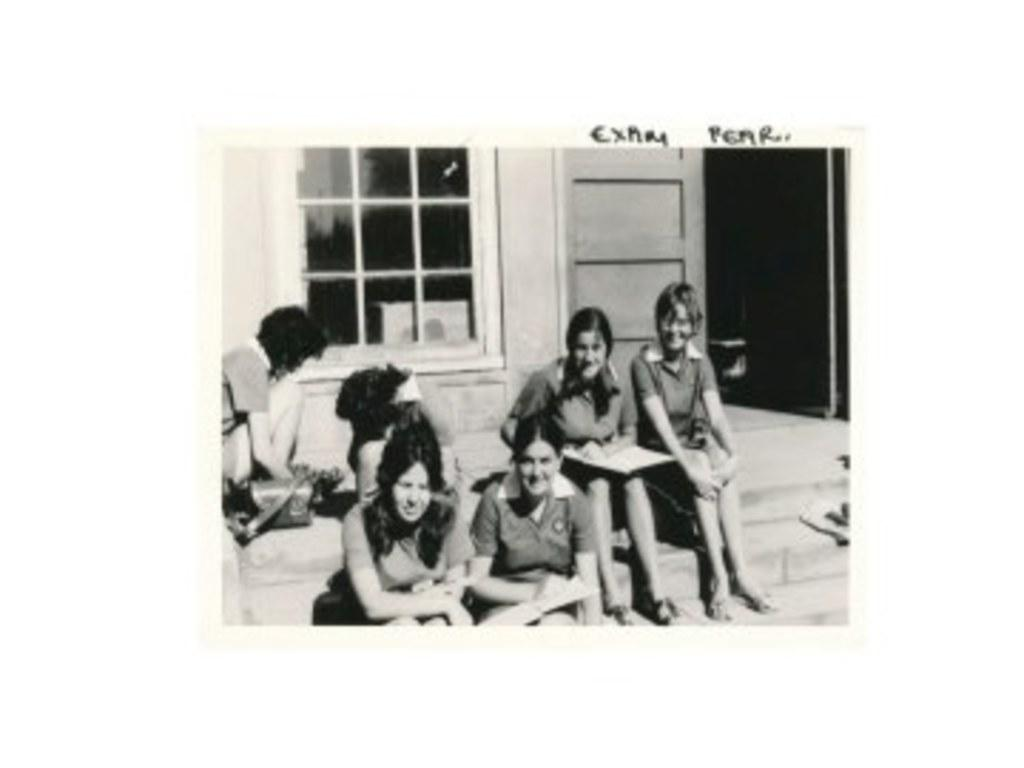What are the people in the image doing? The people in the image are sitting. What can be seen in the background of the image? There is a wall visible in the background of the image. What architectural features are present in the image? There is a door and a window in the image. What hobbies do the parents of the writer in the image have? There is no reference to parents or a writer in the image, so it's not possible to answer that question. 